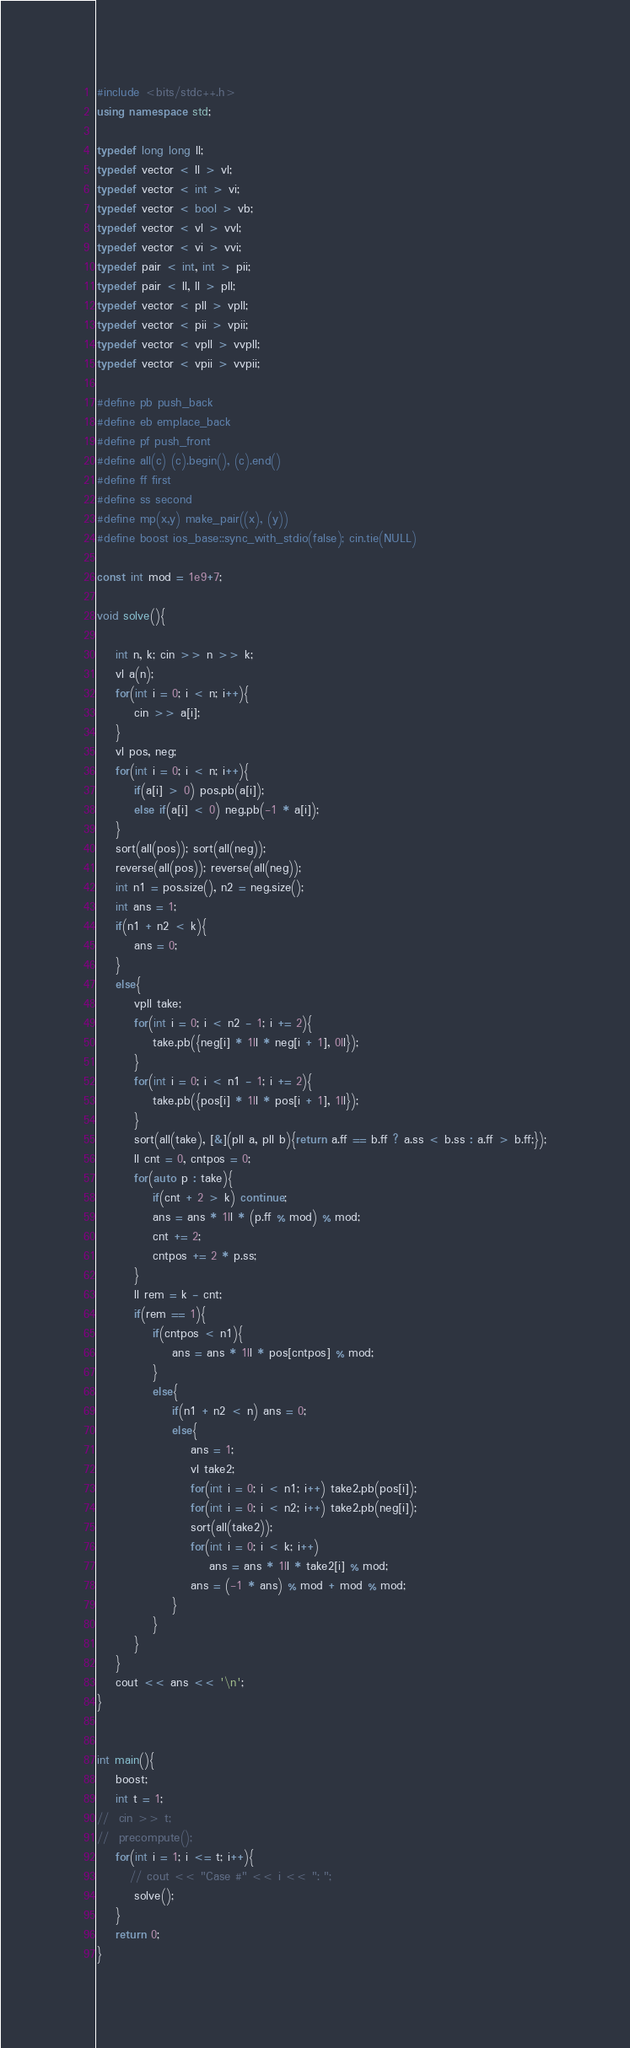Convert code to text. <code><loc_0><loc_0><loc_500><loc_500><_C++_>#include <bits/stdc++.h>
using namespace std;

typedef long long ll;
typedef vector < ll > vl;
typedef vector < int > vi;
typedef vector < bool > vb;
typedef vector < vl > vvl;
typedef vector < vi > vvi;
typedef pair < int, int > pii;
typedef pair < ll, ll > pll;
typedef vector < pll > vpll;
typedef vector < pii > vpii;
typedef vector < vpll > vvpll;
typedef vector < vpii > vvpii;

#define pb push_back
#define eb emplace_back
#define pf push_front
#define all(c) (c).begin(), (c).end()
#define ff first
#define ss second
#define mp(x,y) make_pair((x), (y))
#define boost ios_base::sync_with_stdio(false); cin.tie(NULL)

const int mod = 1e9+7;

void solve(){
    
    int n, k; cin >> n >> k;
    vl a(n);
    for(int i = 0; i < n; i++){
        cin >> a[i];
    }
    vl pos, neg;
    for(int i = 0; i < n; i++){
        if(a[i] > 0) pos.pb(a[i]);
        else if(a[i] < 0) neg.pb(-1 * a[i]);
    }
    sort(all(pos)); sort(all(neg));
    reverse(all(pos)); reverse(all(neg));
    int n1 = pos.size(), n2 = neg.size();
    int ans = 1;
    if(n1 + n2 < k){
        ans = 0;
    }
    else{
        vpll take;
        for(int i = 0; i < n2 - 1; i += 2){
            take.pb({neg[i] * 1ll * neg[i + 1], 0ll});
        }
        for(int i = 0; i < n1 - 1; i += 2){
            take.pb({pos[i] * 1ll * pos[i + 1], 1ll});
        }
        sort(all(take), [&](pll a, pll b){return a.ff == b.ff ? a.ss < b.ss : a.ff > b.ff;});
        ll cnt = 0, cntpos = 0;
        for(auto p : take){
            if(cnt + 2 > k) continue;
            ans = ans * 1ll * (p.ff % mod) % mod;
            cnt += 2;
            cntpos += 2 * p.ss;
        }
        ll rem = k - cnt;
        if(rem == 1){
            if(cntpos < n1){
                ans = ans * 1ll * pos[cntpos] % mod;
            }
            else{
                if(n1 + n2 < n) ans = 0;
                else{
                    ans = 1;
                    vl take2;
                    for(int i = 0; i < n1; i++) take2.pb(pos[i]);
                    for(int i = 0; i < n2; i++) take2.pb(neg[i]);
                    sort(all(take2));
                    for(int i = 0; i < k; i++)
                        ans = ans * 1ll * take2[i] % mod;
                    ans = (-1 * ans) % mod + mod % mod;
                }
            }
        }
    }
    cout << ans << '\n';
}


int main(){
	boost;
	int t = 1;
// 	cin >> t;
// 	precompute();
	for(int i = 1; i <= t; i++){
	   // cout << "Case #" << i << ": ";
		solve();
	}
	return 0;
}</code> 